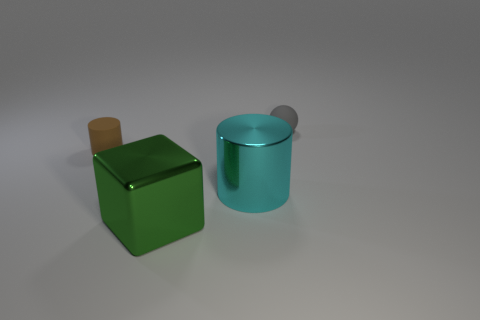Add 3 small blue blocks. How many objects exist? 7 Subtract all spheres. How many objects are left? 3 Add 2 small metal cylinders. How many small metal cylinders exist? 2 Subtract 0 blue cubes. How many objects are left? 4 Subtract all tiny things. Subtract all big blue spheres. How many objects are left? 2 Add 1 small matte cylinders. How many small matte cylinders are left? 2 